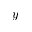<formula> <loc_0><loc_0><loc_500><loc_500>y</formula> 